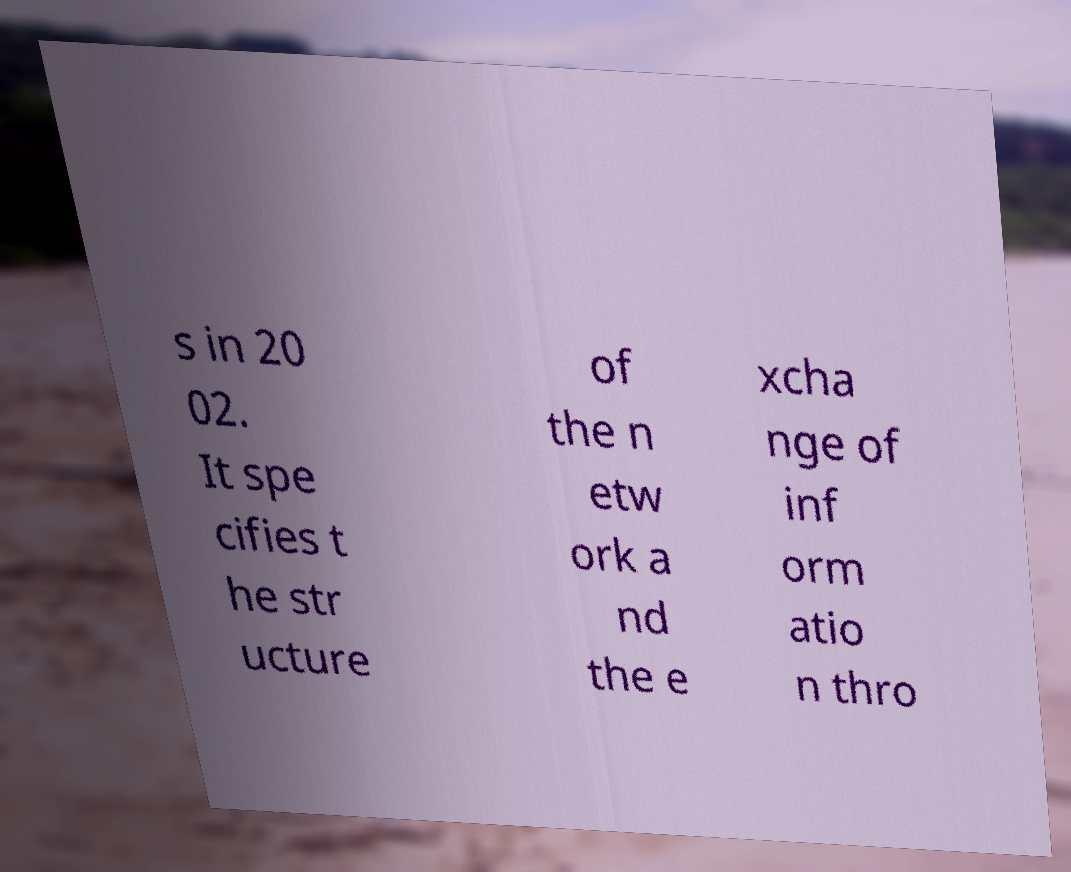Can you read and provide the text displayed in the image?This photo seems to have some interesting text. Can you extract and type it out for me? s in 20 02. It spe cifies t he str ucture of the n etw ork a nd the e xcha nge of inf orm atio n thro 